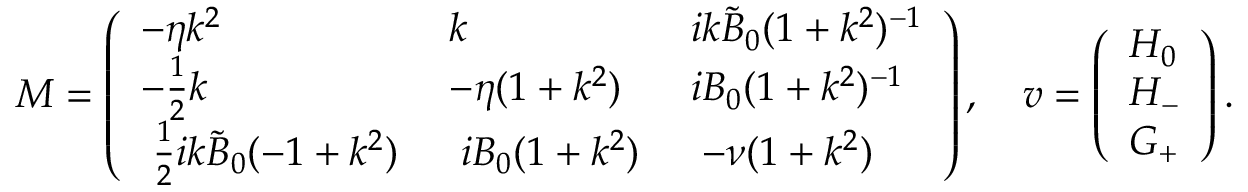<formula> <loc_0><loc_0><loc_500><loc_500>M = \left ( \begin{array} { l l l } { - \eta k ^ { 2 } } & { k } & { i k \tilde { B } _ { 0 } ( 1 + k ^ { 2 } ) ^ { - 1 } } \\ { - \frac { 1 } { 2 } k } & { - \eta ( 1 + k ^ { 2 } ) } & { i B _ { 0 } ( 1 + k ^ { 2 } ) ^ { - 1 } } \\ { \, \frac { 1 } { 2 } i k \tilde { B } _ { 0 } ( - 1 + k ^ { 2 } ) \, } & { \, i B _ { 0 } ( 1 + k ^ { 2 } ) \, } & { \, - \nu ( 1 + k ^ { 2 } ) \, } \end{array} \right ) , \quad v = \left ( \begin{array} { l } { H _ { 0 } } \\ { H _ { - } } \\ { G _ { + } } \end{array} \right ) .</formula> 